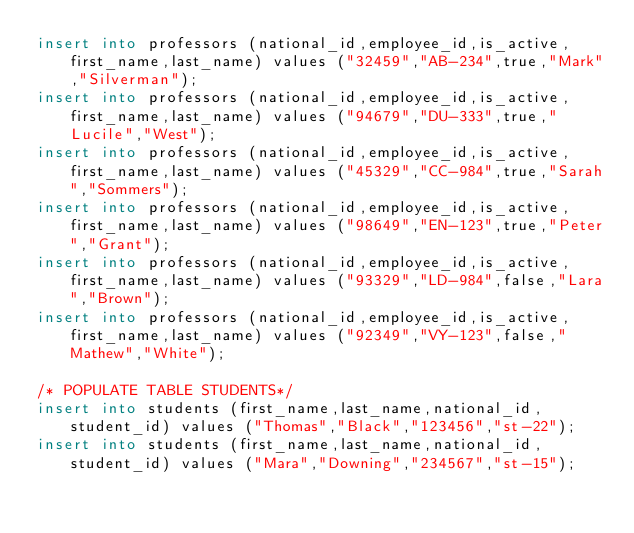Convert code to text. <code><loc_0><loc_0><loc_500><loc_500><_SQL_>insert into professors (national_id,employee_id,is_active,first_name,last_name) values ("32459","AB-234",true,"Mark","Silverman");
insert into professors (national_id,employee_id,is_active,first_name,last_name) values ("94679","DU-333",true,"Lucile","West");
insert into professors (national_id,employee_id,is_active,first_name,last_name) values ("45329","CC-984",true,"Sarah","Sommers");
insert into professors (national_id,employee_id,is_active,first_name,last_name) values ("98649","EN-123",true,"Peter","Grant");
insert into professors (national_id,employee_id,is_active,first_name,last_name) values ("93329","LD-984",false,"Lara","Brown");
insert into professors (national_id,employee_id,is_active,first_name,last_name) values ("92349","VY-123",false,"Mathew","White");

/* POPULATE TABLE STUDENTS*/
insert into students (first_name,last_name,national_id,student_id) values ("Thomas","Black","123456","st-22");
insert into students (first_name,last_name,national_id,student_id) values ("Mara","Downing","234567","st-15");</code> 